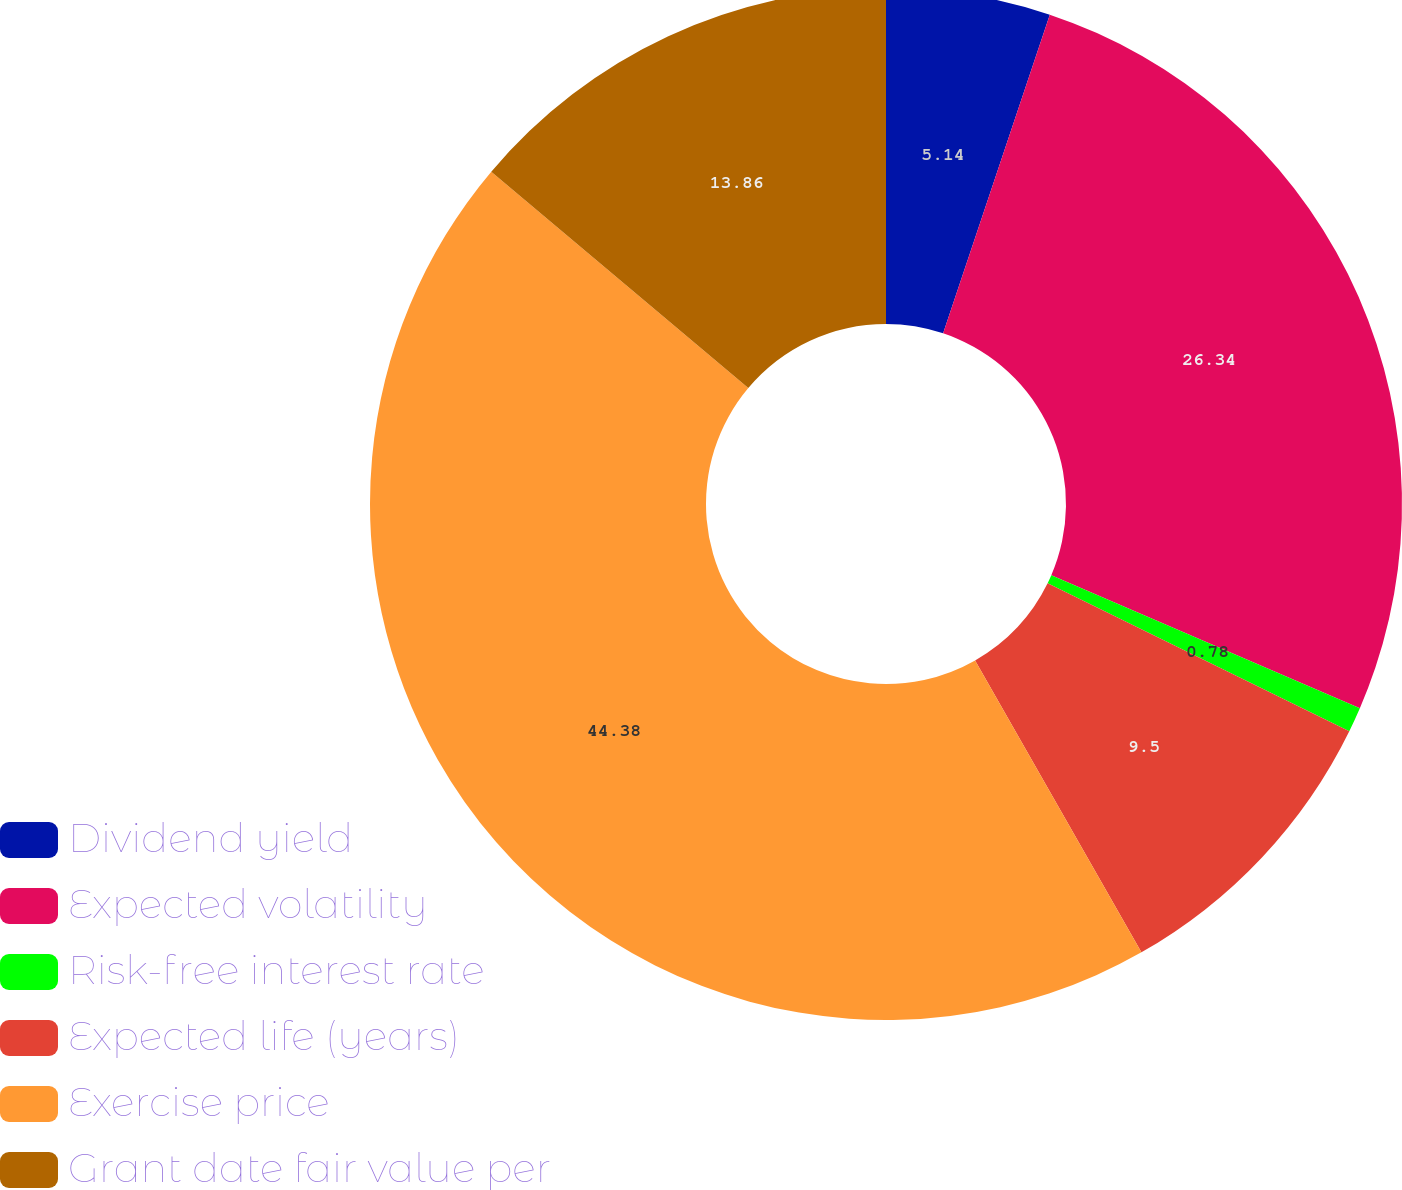<chart> <loc_0><loc_0><loc_500><loc_500><pie_chart><fcel>Dividend yield<fcel>Expected volatility<fcel>Risk-free interest rate<fcel>Expected life (years)<fcel>Exercise price<fcel>Grant date fair value per<nl><fcel>5.14%<fcel>26.33%<fcel>0.78%<fcel>9.5%<fcel>44.37%<fcel>13.86%<nl></chart> 